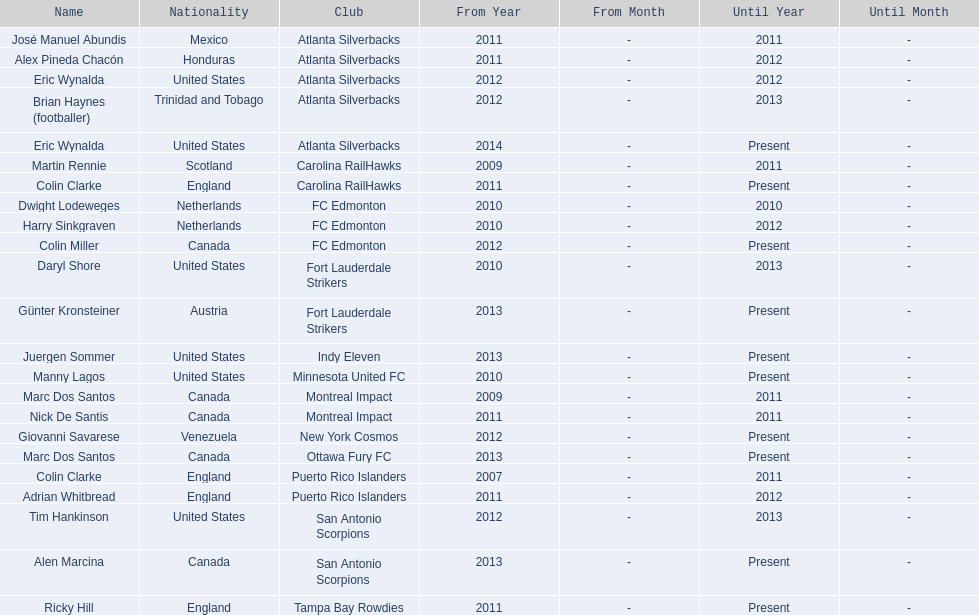What year did marc dos santos start as coach? 2009. Which other starting years correspond with this year? 2009. Who was the other coach with this starting year Martin Rennie. 